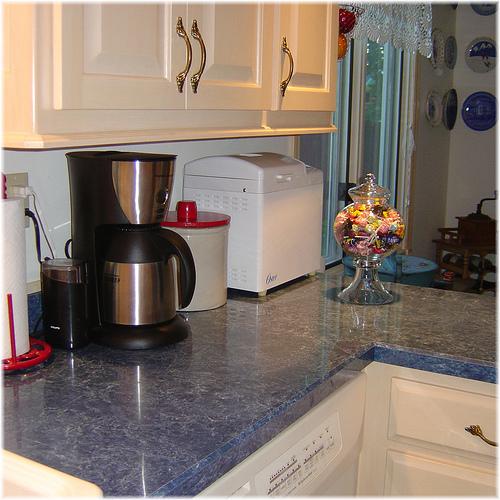Is the countertop granite?
Quick response, please. Yes. What are hanging on the wall?
Answer briefly. Plates. What is in the jar on the counter?
Answer briefly. Candy. 